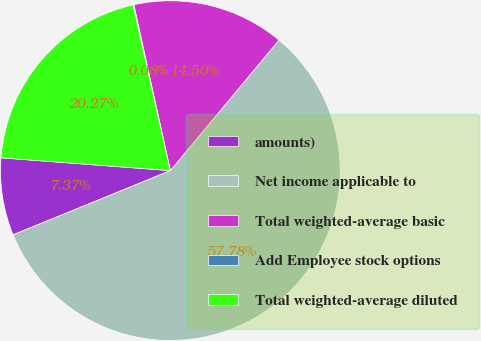<chart> <loc_0><loc_0><loc_500><loc_500><pie_chart><fcel>amounts)<fcel>Net income applicable to<fcel>Total weighted-average basic<fcel>Add Employee stock options<fcel>Total weighted-average diluted<nl><fcel>7.37%<fcel>57.78%<fcel>14.5%<fcel>0.08%<fcel>20.27%<nl></chart> 